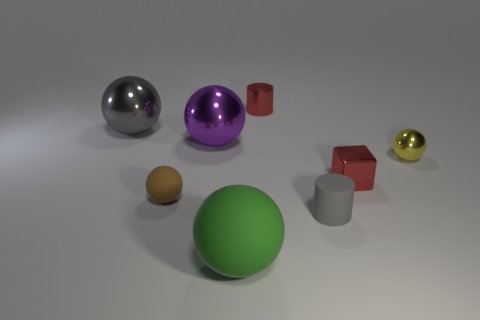How many metal things are either brown things or tiny purple objects?
Give a very brief answer. 0. How many metallic spheres are on the right side of the big green ball and on the left side of the small brown matte thing?
Offer a very short reply. 0. Is there any other thing that has the same shape as the small yellow thing?
Keep it short and to the point. Yes. How many other things are the same size as the gray rubber cylinder?
Provide a short and direct response. 4. Do the ball right of the green rubber ball and the rubber ball that is in front of the tiny brown ball have the same size?
Provide a succinct answer. No. How many things are small metallic balls or objects that are on the right side of the small brown rubber object?
Ensure brevity in your answer.  6. What is the size of the gray object that is to the right of the brown matte thing?
Provide a succinct answer. Small. Is the number of green things that are on the left side of the tiny matte cylinder less than the number of big gray metal balls that are in front of the green sphere?
Keep it short and to the point. No. What is the material of the large sphere that is both right of the large gray metal object and behind the green rubber thing?
Keep it short and to the point. Metal. What is the shape of the gray thing that is behind the small sphere that is on the right side of the tiny gray rubber thing?
Provide a succinct answer. Sphere. 